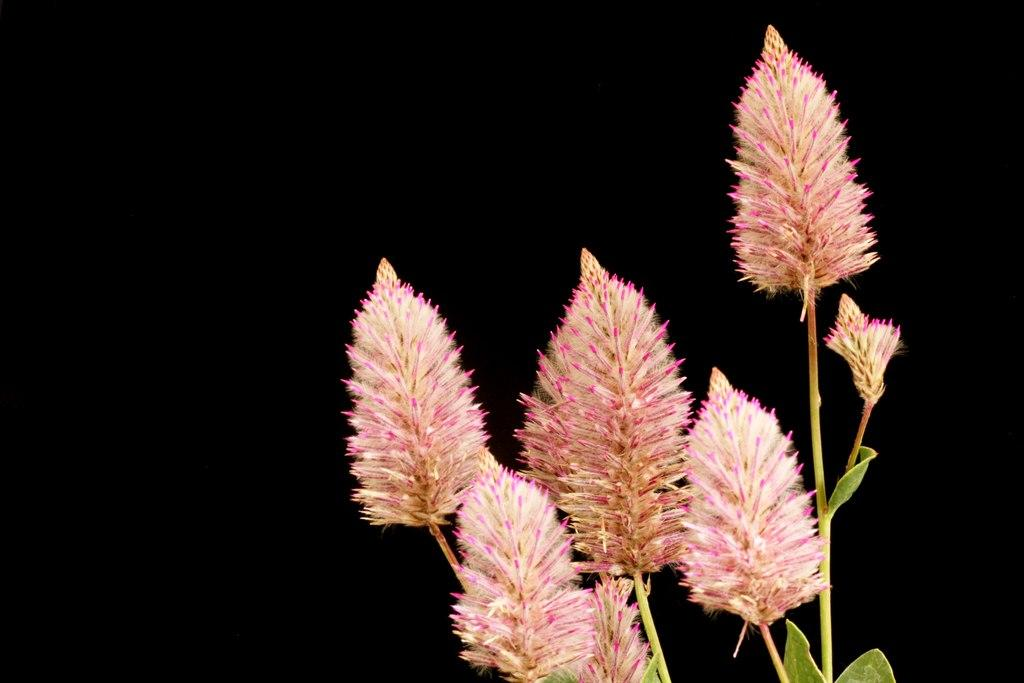What type of living organisms can be seen in the image? There are flowers in the image. Where are the flowers located? The flowers are on plants. What colors are the flowers in the image? The flowers are in pink and cream colors. What is the color of the background in the image? The background of the image is black. What type of ring can be seen on the finger of the achiever in the image? There is no achiever or ring present in the image; it only features flowers on plants with a black background. 